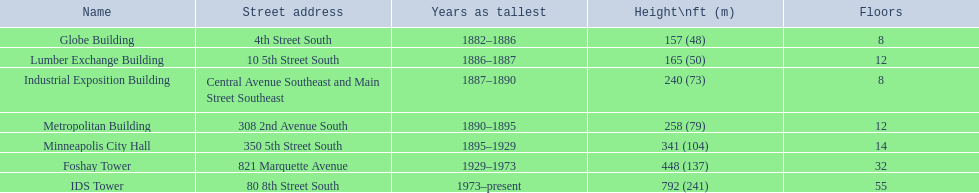How many stories are there in the foshay tower? 32. 